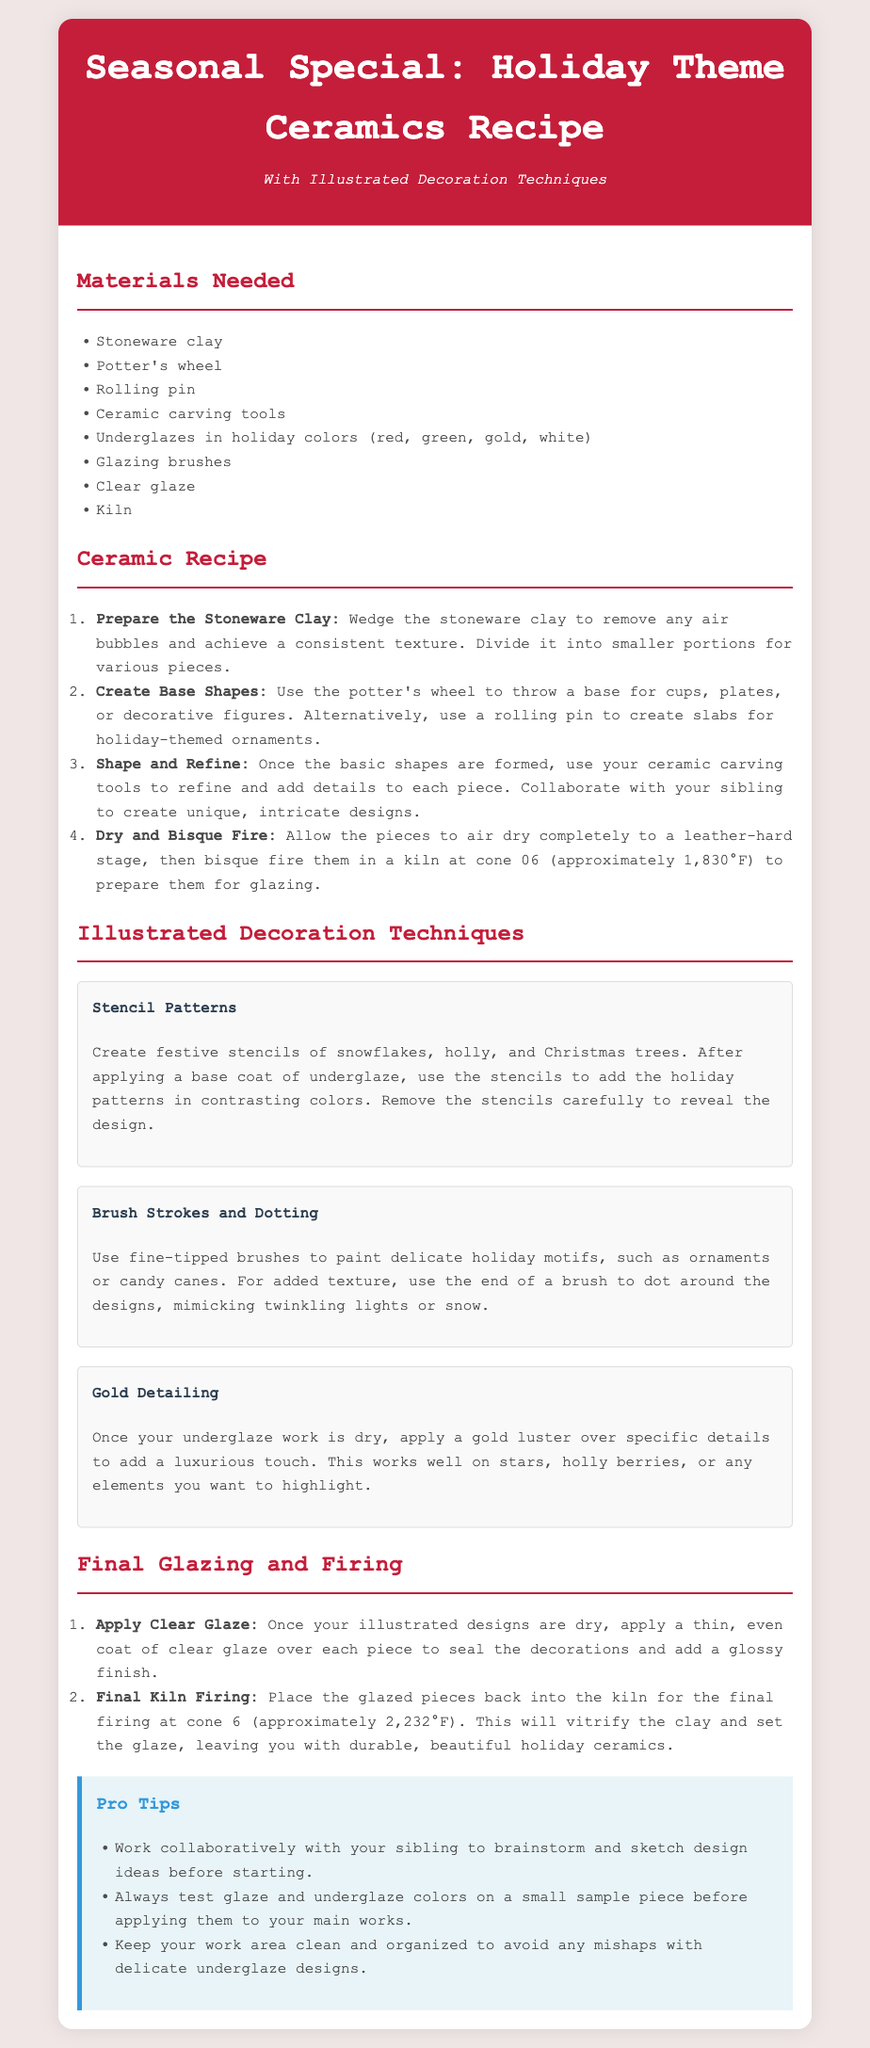What type of clay is used in this recipe? The recipe specifies the use of stoneware clay.
Answer: Stoneware clay How many colors of underglaze are mentioned? The document lists four colors of underglaze in the materials needed section.
Answer: Four What is the firing temperature for bisque firing? The document states that bisque firing occurs at cone 06, which is approximately 1,830°F.
Answer: 1,830°F Which technique involves using stencils? The illustrated decoration techniques section mentions creating festive stencils for patterns.
Answer: Stencil Patterns What should be applied over illustrated designs? The final glazing step indicates that a clear glaze should be applied over the designs.
Answer: Clear glaze Why is it recommended to test glaze colors on a sample piece? The pro tip suggests testing colors to avoid possible mishaps on main works.
Answer: To avoid mishaps What kind of brush is suggested for painting delicate motifs? The document advises using fine-tipped brushes for painting delicate holiday motifs.
Answer: Fine-tipped brushes What are two types of shapes you can create using the potter's wheel? The ceramic recipe section mentions creating bases for cups or plates.
Answer: Cups or plates Who should you collaborate with while brainstorming designs? The pro tips section mentions working collaboratively with your sibling.
Answer: Sibling 